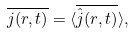Convert formula to latex. <formula><loc_0><loc_0><loc_500><loc_500>\overline { j ( r , t ) } = \langle \overline { \hat { j } ( r , t ) } \rangle ,</formula> 